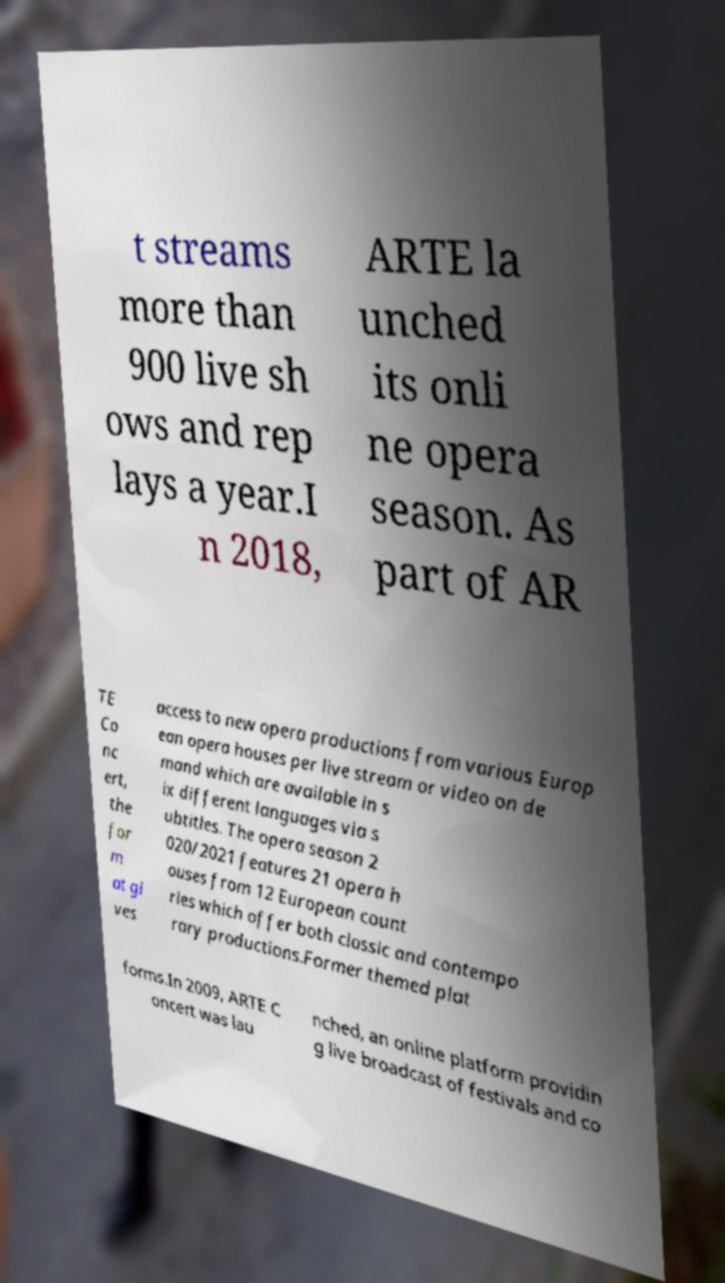Can you read and provide the text displayed in the image?This photo seems to have some interesting text. Can you extract and type it out for me? t streams more than 900 live sh ows and rep lays a year.I n 2018, ARTE la unched its onli ne opera season. As part of AR TE Co nc ert, the for m at gi ves access to new opera productions from various Europ ean opera houses per live stream or video on de mand which are available in s ix different languages via s ubtitles. The opera season 2 020/2021 features 21 opera h ouses from 12 European count ries which offer both classic and contempo rary productions.Former themed plat forms.In 2009, ARTE C oncert was lau nched, an online platform providin g live broadcast of festivals and co 